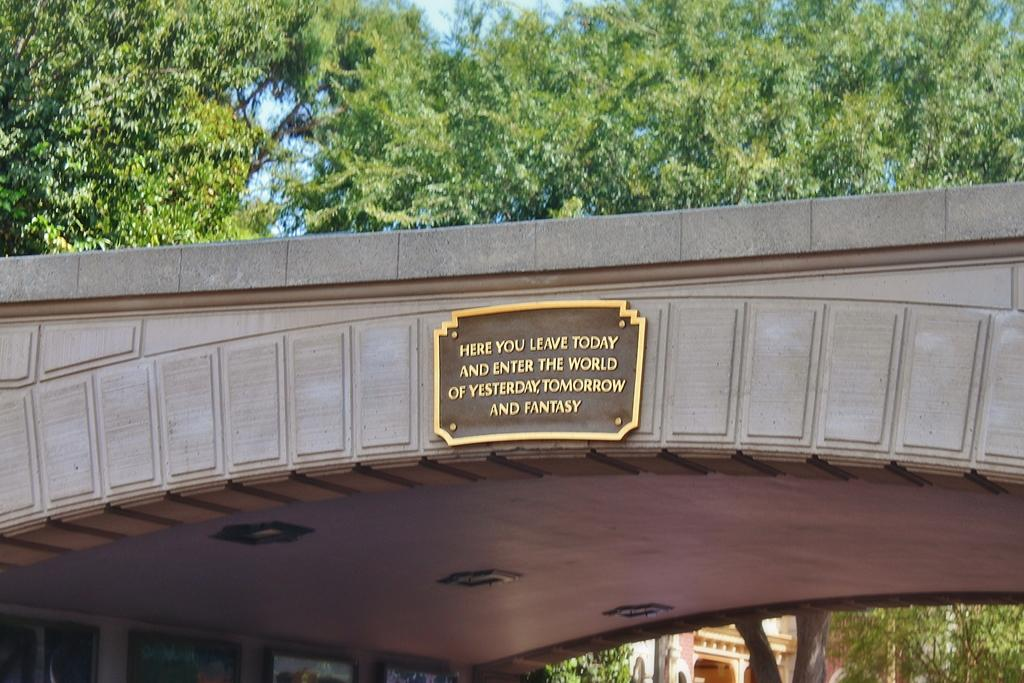<image>
Write a terse but informative summary of the picture. a sign on the side of a bridge that says 'here you leave today and enter the world of yesterday, tomorrow and fantasy' 